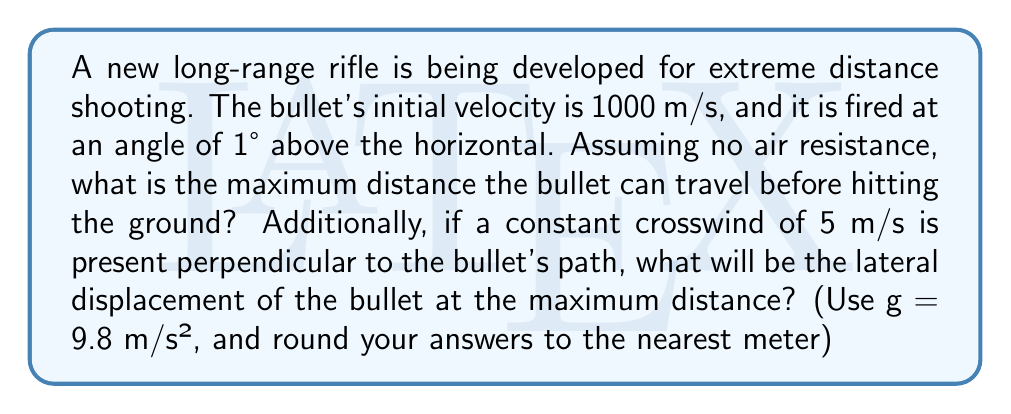Provide a solution to this math problem. 1. Maximum distance calculation:
   We can use the equation for the range of a projectile:
   $$R = \frac{v_0^2 \sin(2\theta)}{g}$$
   Where $v_0$ is the initial velocity, $\theta$ is the launch angle, and $g$ is the acceleration due to gravity.

   $v_0 = 1000$ m/s
   $\theta = 1° = 0.0175$ radians
   $g = 9.8$ m/s²

   $$R = \frac{1000^2 \sin(2 * 0.0175)}{9.8} = 20,408.16$$

2. Time of flight calculation:
   We need this to calculate the lateral displacement.
   $$t = \frac{2v_0 \sin(\theta)}{g}$$

   $$t = \frac{2 * 1000 * \sin(0.0175)}{9.8} = 3.57$$

3. Lateral displacement calculation:
   The lateral displacement is the product of the crosswind velocity and the time of flight.
   $$d = v_{wind} * t$$
   
   $$d = 5 * 3.57 = 17.85$$

Rounding to the nearest meter:
Maximum distance: 20,408 m
Lateral displacement: 18 m
Answer: 20,408 m; 18 m 